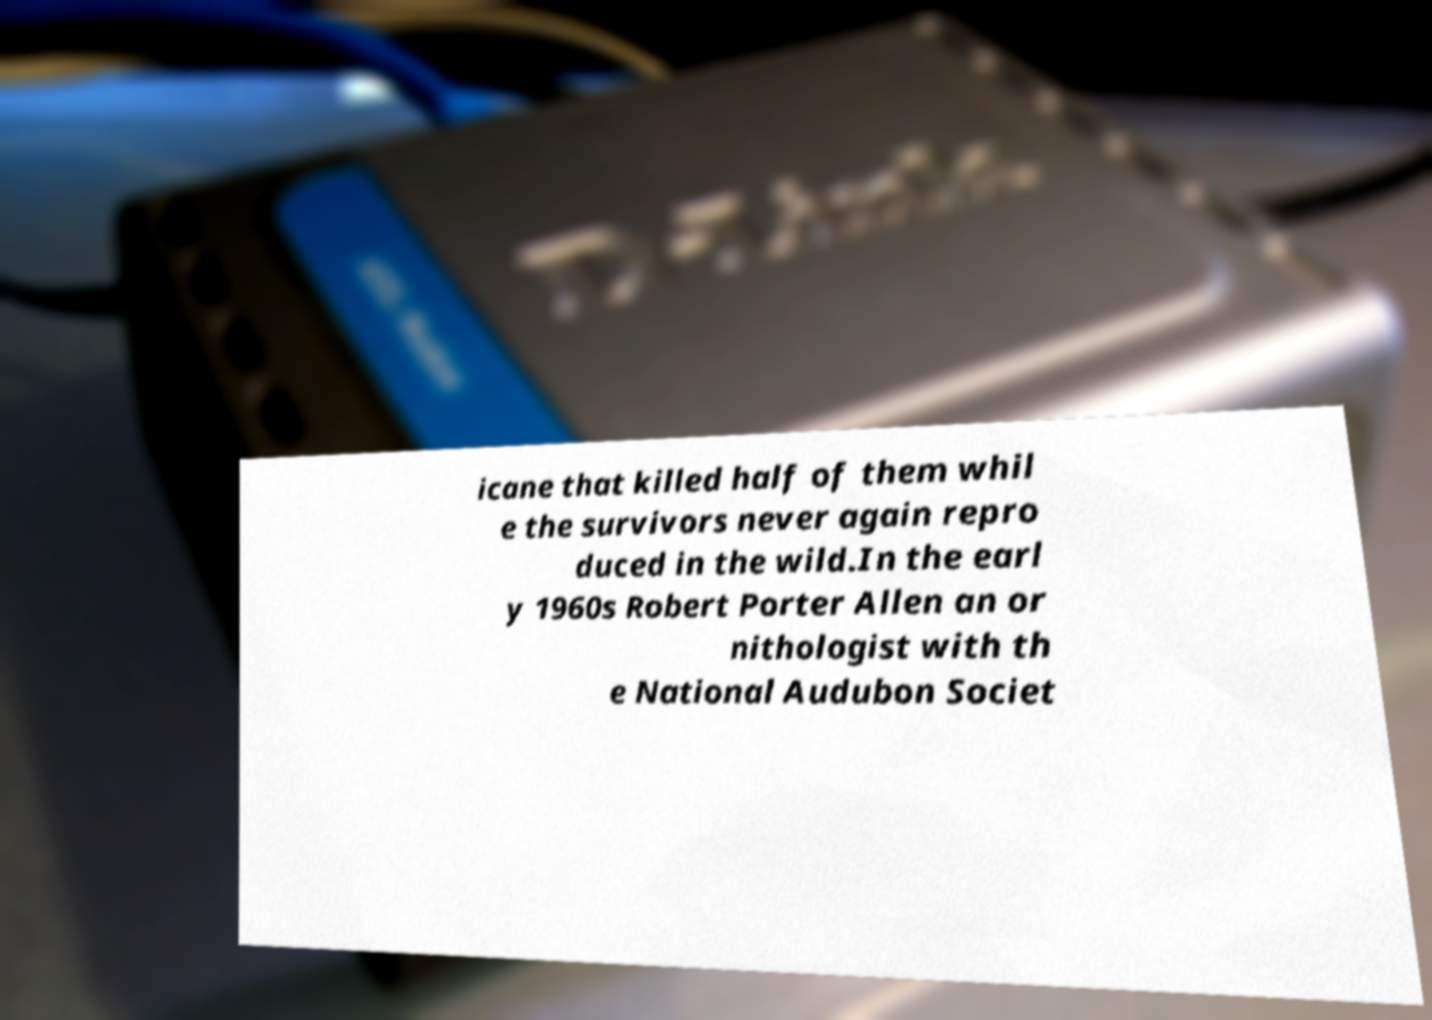For documentation purposes, I need the text within this image transcribed. Could you provide that? icane that killed half of them whil e the survivors never again repro duced in the wild.In the earl y 1960s Robert Porter Allen an or nithologist with th e National Audubon Societ 